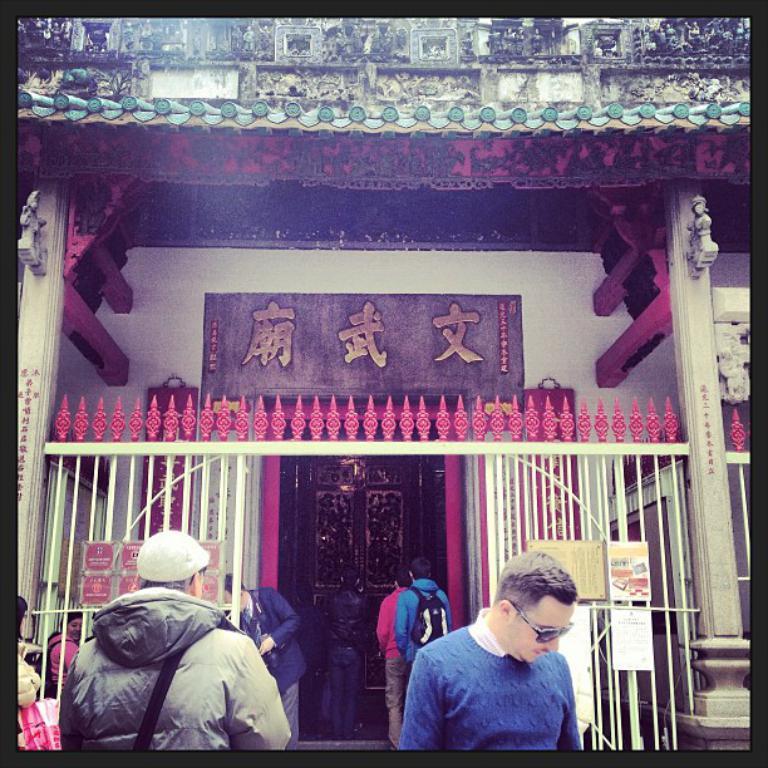Please provide a concise description of this image. In the foreground of this image, there are two persons one in blue sweater and another in grey coat. In the background, there is a building and text in Japanese language and a entrance door at which few persons are walking. 